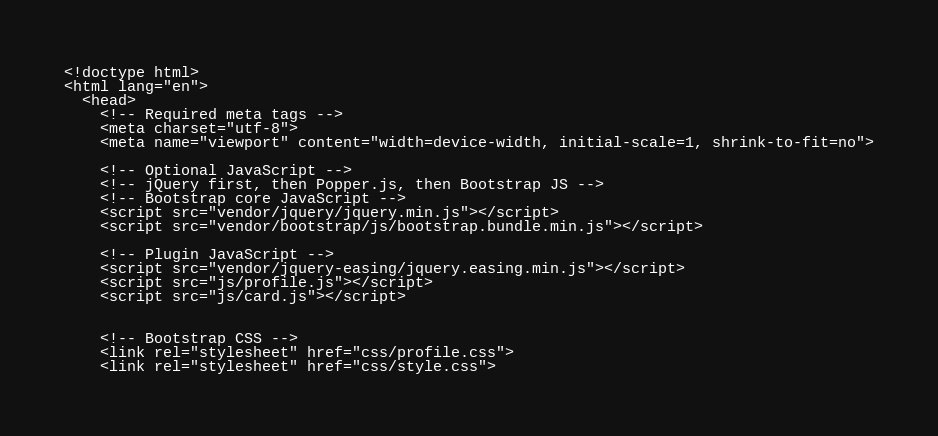<code> <loc_0><loc_0><loc_500><loc_500><_PHP_><!doctype html>
<html lang="en">
  <head>
    <!-- Required meta tags -->
    <meta charset="utf-8">
    <meta name="viewport" content="width=device-width, initial-scale=1, shrink-to-fit=no">

    <!-- Optional JavaScript -->
    <!-- jQuery first, then Popper.js, then Bootstrap JS -->
    <!-- Bootstrap core JavaScript -->
    <script src="vendor/jquery/jquery.min.js"></script>
    <script src="vendor/bootstrap/js/bootstrap.bundle.min.js"></script>

    <!-- Plugin JavaScript -->
    <script src="vendor/jquery-easing/jquery.easing.min.js"></script>
    <script src="js/profile.js"></script>
    <script src="js/card.js"></script>


    <!-- Bootstrap CSS -->
    <link rel="stylesheet" href="css/profile.css">
    <link rel="stylesheet" href="css/style.css"></code> 